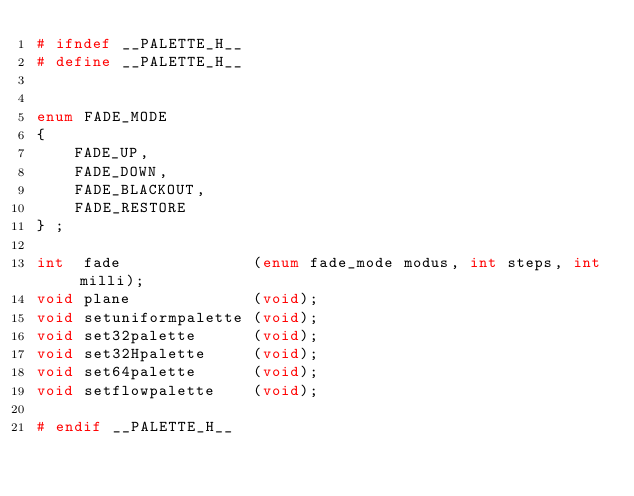<code> <loc_0><loc_0><loc_500><loc_500><_C_># ifndef __PALETTE_H__
# define __PALETTE_H__


enum FADE_MODE
{
    FADE_UP,
    FADE_DOWN,
    FADE_BLACKOUT,
    FADE_RESTORE
} ;

int  fade              (enum fade_mode modus, int steps, int milli);
void plane             (void);
void setuniformpalette (void);
void set32palette      (void);
void set32Hpalette     (void);
void set64palette      (void);
void setflowpalette    (void);

# endif __PALETTE_H__


</code> 